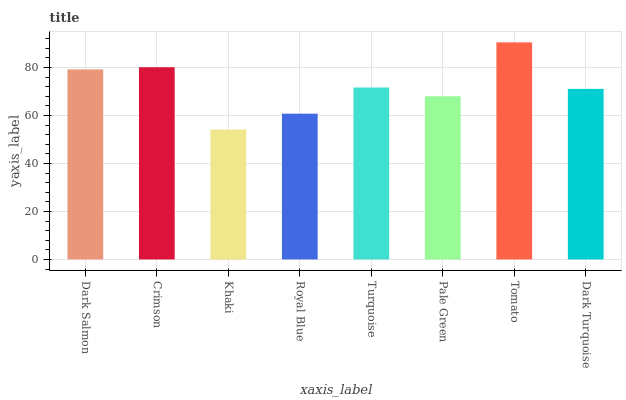Is Crimson the minimum?
Answer yes or no. No. Is Crimson the maximum?
Answer yes or no. No. Is Crimson greater than Dark Salmon?
Answer yes or no. Yes. Is Dark Salmon less than Crimson?
Answer yes or no. Yes. Is Dark Salmon greater than Crimson?
Answer yes or no. No. Is Crimson less than Dark Salmon?
Answer yes or no. No. Is Turquoise the high median?
Answer yes or no. Yes. Is Dark Turquoise the low median?
Answer yes or no. Yes. Is Royal Blue the high median?
Answer yes or no. No. Is Royal Blue the low median?
Answer yes or no. No. 